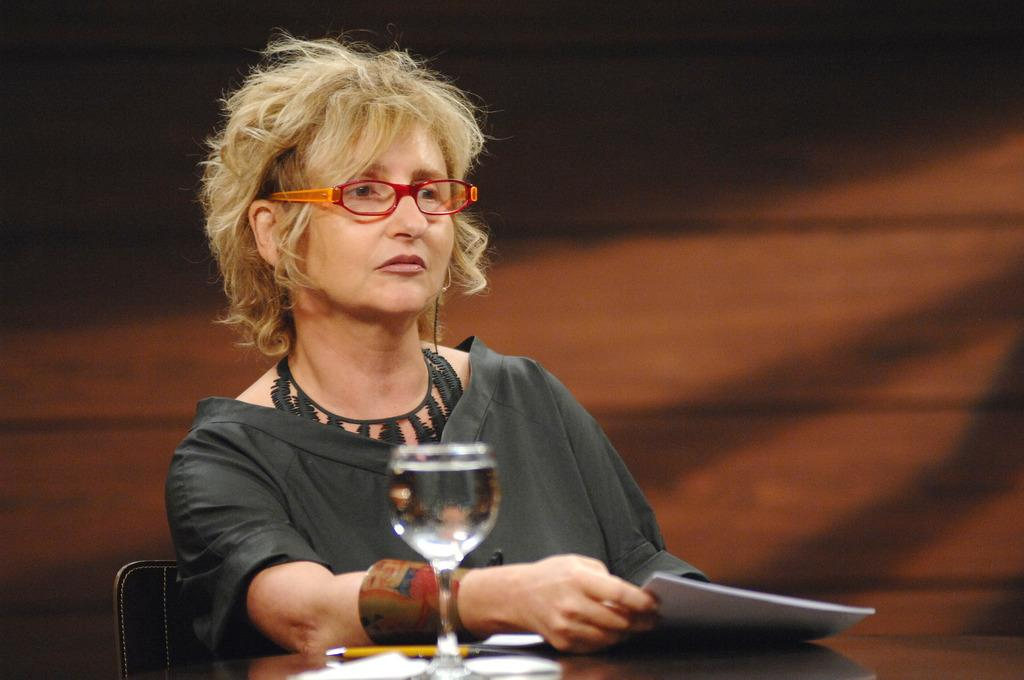What is on the table in the image? There is a glass, papers, and a pen on the table in the image. What might be used for writing on the papers? The pen on the table might be used for writing on the papers. Can you describe the person in the background? In the background, there is a person sitting on a chair. What is the person holding in the background? The person is holding papers in the background. What type of drain can be seen in the image? There is no drain present in the image. What scientific experiment is being conducted in the image? There is no scientific experiment visible in the image. 